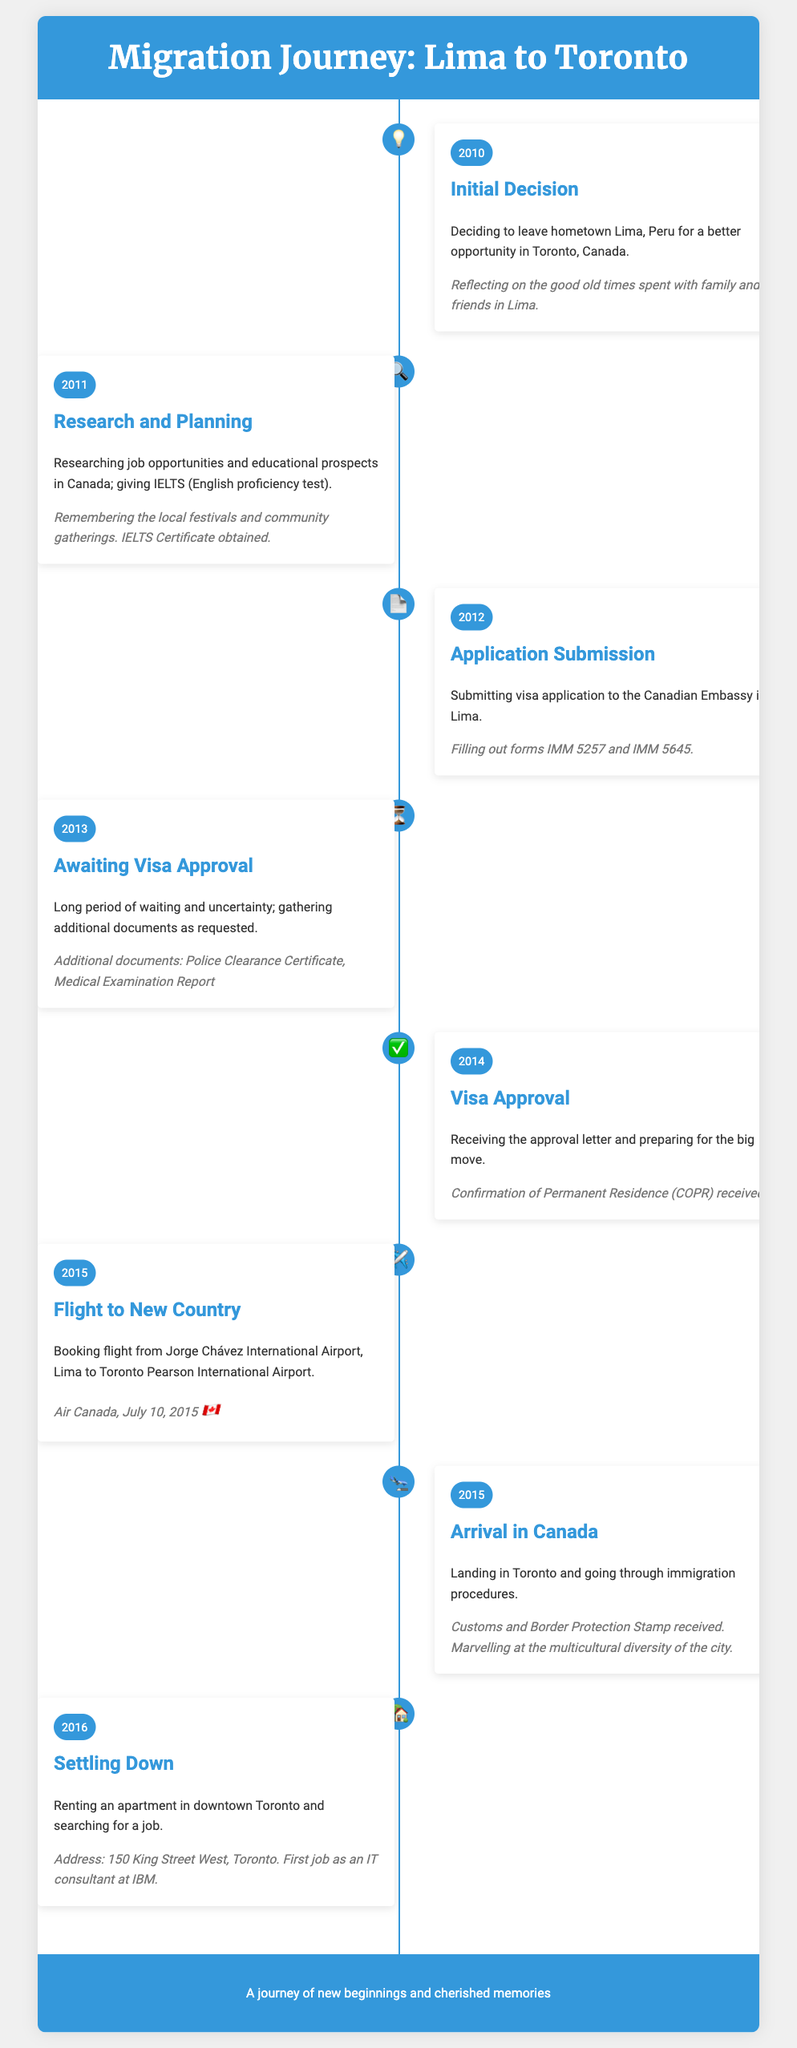What year did the initial decision to migrate occur? The initial decision to leave Lima was made in 2010, as stated in the first timeline item.
Answer: 2010 What document was submitted in 2012? The document submitted for migration in 2012 was the visa application to the Canadian Embassy, as mentioned in the timeline.
Answer: Visa application What was the profession of the first job mentioned? The first job mentioned after settling down in Toronto was as an IT consultant at IBM.
Answer: IT consultant How many years did it take from the initial decision to flight booking? The timeline indicates the decision was made in 2010 and the flight was booked in 2015, showing a duration of 5 years.
Answer: 5 years What was received in 2014 that indicated the move was approved? In 2014, the individual received the confirmation of Permanent Residence (COPR), which indicated the move was approved.
Answer: Confirmation of Permanent Residence What was a key milestone in 2013? The key milestone in 2013 was the awaiting visa approval status, which was a crucial part of the migration process.
Answer: Awaiting Visa Approval How was the arrival in Canada characterized in the timeline? The arrival in Canada was characterized by going through immigration procedures and receiving the Customs and Border Protection Stamp.
Answer: Immigration procedures What did the person reminisce about during the research and planning phase? During the research and planning phase, the person reminisced about local festivals and community gatherings in Lima.
Answer: Local festivals and community gatherings What airline was used for the flight to Canada? The airline used for the flight to Canada was Air Canada, indicated in the timeline for the flight booking in 2015.
Answer: Air Canada 